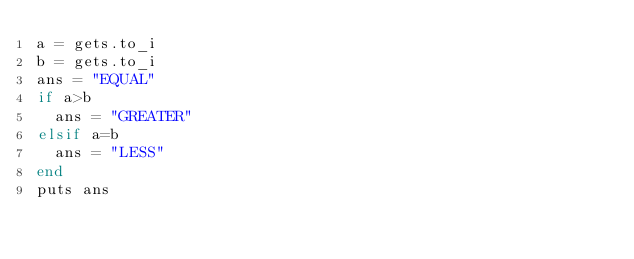<code> <loc_0><loc_0><loc_500><loc_500><_Ruby_>a = gets.to_i
b = gets.to_i
ans = "EQUAL"
if a>b
  ans = "GREATER"
elsif a=b
  ans = "LESS"
end
puts ans
</code> 